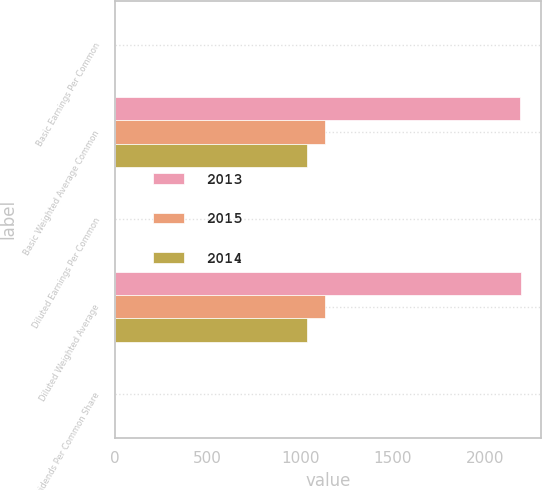Convert chart to OTSL. <chart><loc_0><loc_0><loc_500><loc_500><stacked_bar_chart><ecel><fcel>Basic Earnings Per Common<fcel>Basic Weighted Average Common<fcel>Diluted Earnings Per Common<fcel>Diluted Weighted Average<fcel>Dividends Per Common Share<nl><fcel>2013<fcel>0.1<fcel>2187<fcel>0.1<fcel>2193<fcel>1.6<nl><fcel>2015<fcel>0.89<fcel>1137<fcel>0.89<fcel>1137<fcel>1.74<nl><fcel>2014<fcel>1.15<fcel>1036<fcel>1.15<fcel>1036<fcel>1.6<nl></chart> 